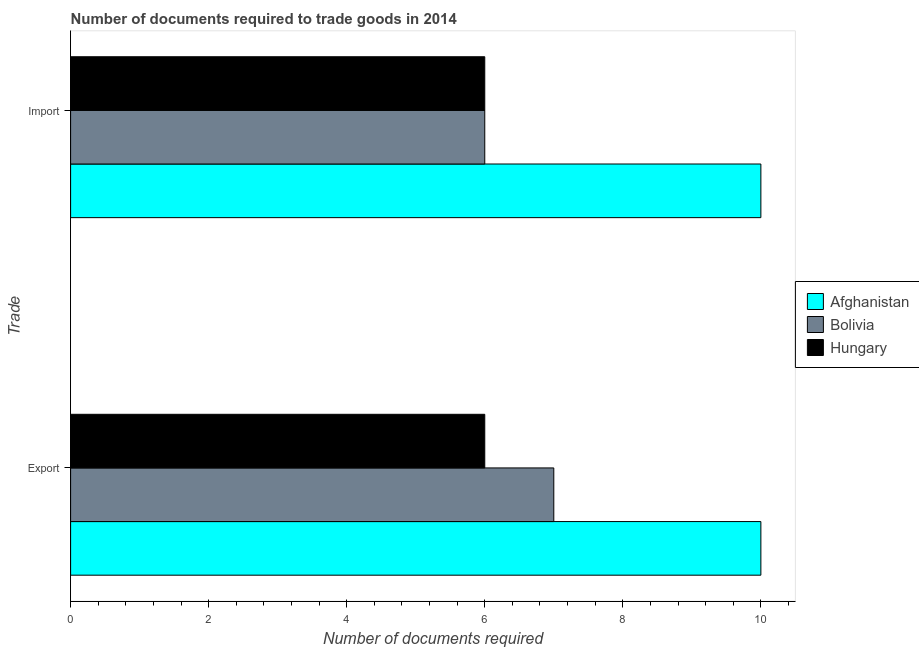Are the number of bars on each tick of the Y-axis equal?
Make the answer very short. Yes. What is the label of the 1st group of bars from the top?
Your answer should be very brief. Import. What is the number of documents required to export goods in Bolivia?
Provide a succinct answer. 7. Across all countries, what is the maximum number of documents required to import goods?
Make the answer very short. 10. In which country was the number of documents required to export goods maximum?
Provide a short and direct response. Afghanistan. In which country was the number of documents required to export goods minimum?
Offer a very short reply. Hungary. What is the total number of documents required to export goods in the graph?
Your response must be concise. 23. What is the difference between the number of documents required to export goods in Bolivia and that in Afghanistan?
Your answer should be very brief. -3. What is the difference between the number of documents required to import goods in Hungary and the number of documents required to export goods in Afghanistan?
Ensure brevity in your answer.  -4. What is the average number of documents required to export goods per country?
Your answer should be very brief. 7.67. What is the ratio of the number of documents required to export goods in Afghanistan to that in Hungary?
Your answer should be compact. 1.67. In how many countries, is the number of documents required to import goods greater than the average number of documents required to import goods taken over all countries?
Your answer should be compact. 1. What does the 1st bar from the bottom in Import represents?
Provide a short and direct response. Afghanistan. How many countries are there in the graph?
Provide a succinct answer. 3. What is the difference between two consecutive major ticks on the X-axis?
Provide a succinct answer. 2. Are the values on the major ticks of X-axis written in scientific E-notation?
Provide a succinct answer. No. Does the graph contain any zero values?
Your response must be concise. No. Does the graph contain grids?
Make the answer very short. No. How many legend labels are there?
Your answer should be compact. 3. What is the title of the graph?
Offer a very short reply. Number of documents required to trade goods in 2014. Does "Benin" appear as one of the legend labels in the graph?
Your answer should be compact. No. What is the label or title of the X-axis?
Ensure brevity in your answer.  Number of documents required. What is the label or title of the Y-axis?
Make the answer very short. Trade. What is the Number of documents required in Bolivia in Export?
Provide a short and direct response. 7. What is the Number of documents required of Hungary in Export?
Provide a succinct answer. 6. What is the Number of documents required in Hungary in Import?
Provide a short and direct response. 6. Across all Trade, what is the maximum Number of documents required in Bolivia?
Offer a very short reply. 7. Across all Trade, what is the minimum Number of documents required of Afghanistan?
Your response must be concise. 10. What is the total Number of documents required in Bolivia in the graph?
Provide a succinct answer. 13. What is the difference between the Number of documents required in Bolivia in Export and that in Import?
Offer a terse response. 1. What is the difference between the Number of documents required in Afghanistan in Export and the Number of documents required in Hungary in Import?
Provide a short and direct response. 4. What is the difference between the Number of documents required in Bolivia in Export and the Number of documents required in Hungary in Import?
Offer a terse response. 1. What is the average Number of documents required of Hungary per Trade?
Provide a short and direct response. 6. What is the difference between the Number of documents required of Afghanistan and Number of documents required of Bolivia in Export?
Your answer should be compact. 3. What is the difference between the Number of documents required in Afghanistan and Number of documents required in Hungary in Export?
Offer a very short reply. 4. What is the difference between the Number of documents required of Bolivia and Number of documents required of Hungary in Export?
Ensure brevity in your answer.  1. What is the difference between the Number of documents required in Afghanistan and Number of documents required in Bolivia in Import?
Your response must be concise. 4. What is the difference between the Number of documents required of Afghanistan and Number of documents required of Hungary in Import?
Your answer should be very brief. 4. What is the difference between the Number of documents required in Bolivia and Number of documents required in Hungary in Import?
Keep it short and to the point. 0. What is the ratio of the Number of documents required in Bolivia in Export to that in Import?
Ensure brevity in your answer.  1.17. What is the ratio of the Number of documents required of Hungary in Export to that in Import?
Offer a very short reply. 1. What is the difference between the highest and the second highest Number of documents required in Bolivia?
Give a very brief answer. 1. What is the difference between the highest and the second highest Number of documents required in Hungary?
Your response must be concise. 0. 